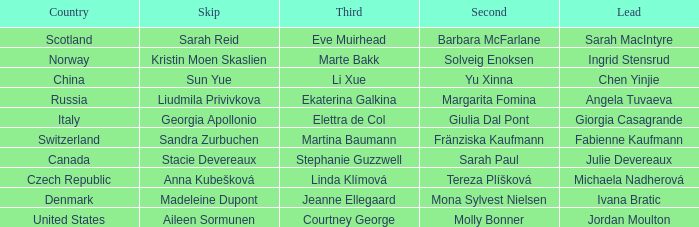What skip has norway as the country? Kristin Moen Skaslien. 